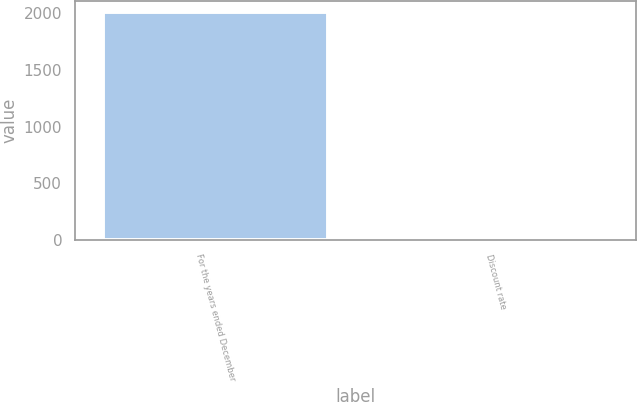Convert chart. <chart><loc_0><loc_0><loc_500><loc_500><bar_chart><fcel>For the years ended December<fcel>Discount rate<nl><fcel>2013<fcel>3.7<nl></chart> 